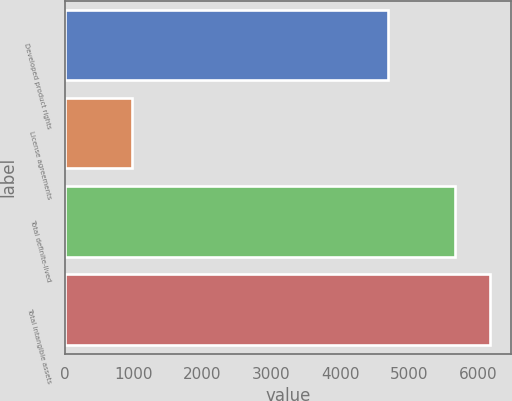<chart> <loc_0><loc_0><loc_500><loc_500><bar_chart><fcel>Developed product rights<fcel>License agreements<fcel>Total definite-lived<fcel>Total intangible assets<nl><fcel>4699<fcel>969<fcel>5668<fcel>6179.9<nl></chart> 